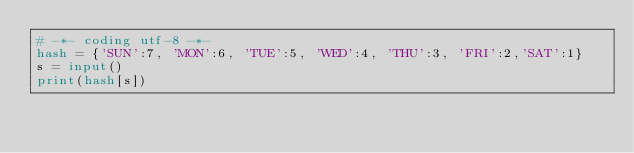Convert code to text. <code><loc_0><loc_0><loc_500><loc_500><_Python_># -*- coding utf-8 -*-
hash = {'SUN':7, 'MON':6, 'TUE':5, 'WED':4, 'THU':3, 'FRI':2,'SAT':1}
s = input()
print(hash[s])
</code> 